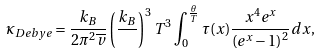Convert formula to latex. <formula><loc_0><loc_0><loc_500><loc_500>\kappa _ { D e b y e } = \frac { k _ { B } } { 2 \pi ^ { 2 } \overline { v } } \left ( \frac { k _ { B } } { } \right ) ^ { 3 } T ^ { 3 } \int _ { 0 } ^ { \frac { \theta } { T } } \tau ( x ) \frac { x ^ { 4 } e ^ { x } } { \left ( e ^ { x } - 1 \right ) ^ { 2 } } d x ,</formula> 